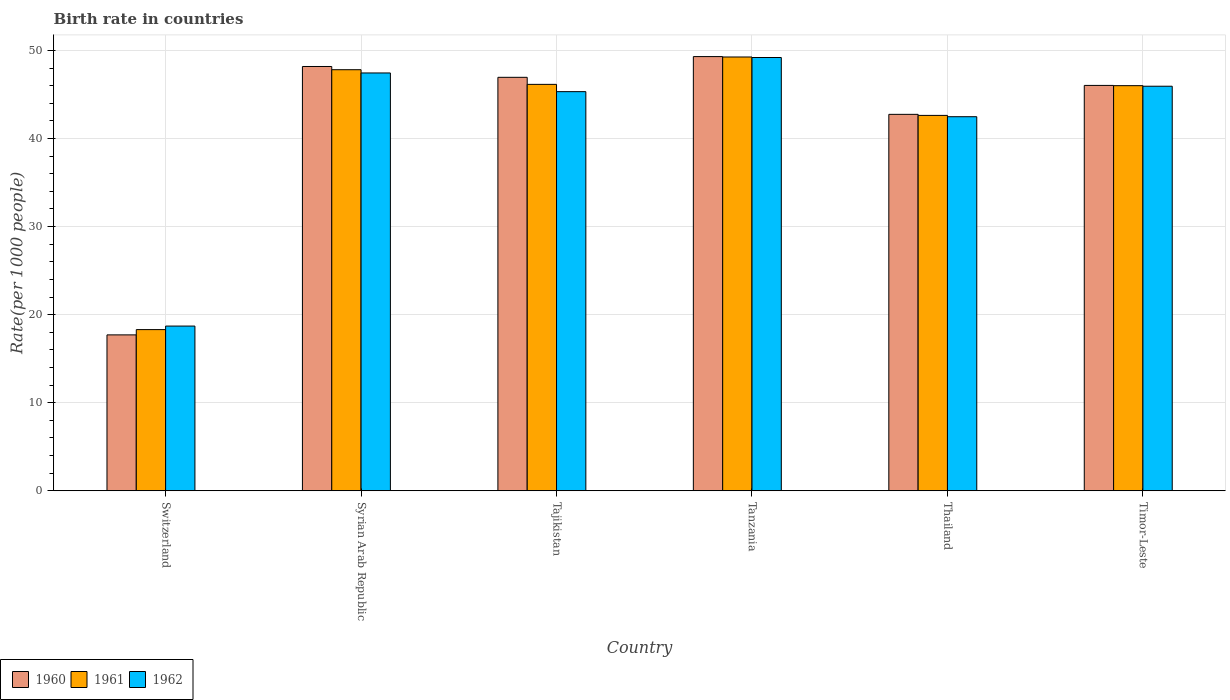Are the number of bars per tick equal to the number of legend labels?
Offer a very short reply. Yes. Are the number of bars on each tick of the X-axis equal?
Provide a short and direct response. Yes. What is the label of the 5th group of bars from the left?
Provide a short and direct response. Thailand. In how many cases, is the number of bars for a given country not equal to the number of legend labels?
Keep it short and to the point. 0. What is the birth rate in 1961 in Syrian Arab Republic?
Give a very brief answer. 47.8. Across all countries, what is the maximum birth rate in 1962?
Keep it short and to the point. 49.19. In which country was the birth rate in 1960 maximum?
Your answer should be compact. Tanzania. In which country was the birth rate in 1961 minimum?
Provide a short and direct response. Switzerland. What is the total birth rate in 1960 in the graph?
Your answer should be very brief. 250.87. What is the difference between the birth rate in 1961 in Tanzania and that in Timor-Leste?
Your answer should be compact. 3.26. What is the difference between the birth rate in 1961 in Switzerland and the birth rate in 1962 in Timor-Leste?
Your answer should be compact. -27.63. What is the average birth rate in 1960 per country?
Provide a succinct answer. 41.81. What is the difference between the birth rate of/in 1960 and birth rate of/in 1961 in Tanzania?
Your answer should be compact. 0.05. What is the ratio of the birth rate in 1962 in Tanzania to that in Timor-Leste?
Give a very brief answer. 1.07. Is the birth rate in 1962 in Switzerland less than that in Timor-Leste?
Offer a terse response. Yes. What is the difference between the highest and the second highest birth rate in 1962?
Keep it short and to the point. 3.26. What is the difference between the highest and the lowest birth rate in 1962?
Keep it short and to the point. 30.49. In how many countries, is the birth rate in 1961 greater than the average birth rate in 1961 taken over all countries?
Your answer should be compact. 5. How many bars are there?
Keep it short and to the point. 18. Are all the bars in the graph horizontal?
Your answer should be compact. No. How many countries are there in the graph?
Keep it short and to the point. 6. What is the difference between two consecutive major ticks on the Y-axis?
Offer a very short reply. 10. How many legend labels are there?
Ensure brevity in your answer.  3. What is the title of the graph?
Your response must be concise. Birth rate in countries. What is the label or title of the Y-axis?
Your answer should be very brief. Rate(per 1000 people). What is the Rate(per 1000 people) in 1960 in Switzerland?
Provide a short and direct response. 17.7. What is the Rate(per 1000 people) of 1961 in Switzerland?
Offer a very short reply. 18.3. What is the Rate(per 1000 people) of 1960 in Syrian Arab Republic?
Provide a succinct answer. 48.17. What is the Rate(per 1000 people) in 1961 in Syrian Arab Republic?
Provide a succinct answer. 47.8. What is the Rate(per 1000 people) of 1962 in Syrian Arab Republic?
Provide a short and direct response. 47.44. What is the Rate(per 1000 people) in 1960 in Tajikistan?
Offer a very short reply. 46.94. What is the Rate(per 1000 people) of 1961 in Tajikistan?
Provide a succinct answer. 46.14. What is the Rate(per 1000 people) of 1962 in Tajikistan?
Keep it short and to the point. 45.31. What is the Rate(per 1000 people) in 1960 in Tanzania?
Your response must be concise. 49.3. What is the Rate(per 1000 people) in 1961 in Tanzania?
Ensure brevity in your answer.  49.25. What is the Rate(per 1000 people) in 1962 in Tanzania?
Your response must be concise. 49.19. What is the Rate(per 1000 people) of 1960 in Thailand?
Give a very brief answer. 42.74. What is the Rate(per 1000 people) in 1961 in Thailand?
Provide a short and direct response. 42.62. What is the Rate(per 1000 people) of 1962 in Thailand?
Provide a short and direct response. 42.47. What is the Rate(per 1000 people) of 1960 in Timor-Leste?
Keep it short and to the point. 46.02. What is the Rate(per 1000 people) of 1961 in Timor-Leste?
Your answer should be very brief. 45.99. What is the Rate(per 1000 people) in 1962 in Timor-Leste?
Your answer should be very brief. 45.93. Across all countries, what is the maximum Rate(per 1000 people) in 1960?
Your response must be concise. 49.3. Across all countries, what is the maximum Rate(per 1000 people) of 1961?
Ensure brevity in your answer.  49.25. Across all countries, what is the maximum Rate(per 1000 people) in 1962?
Provide a short and direct response. 49.19. Across all countries, what is the minimum Rate(per 1000 people) in 1960?
Your answer should be compact. 17.7. Across all countries, what is the minimum Rate(per 1000 people) of 1962?
Your answer should be compact. 18.7. What is the total Rate(per 1000 people) of 1960 in the graph?
Your answer should be compact. 250.87. What is the total Rate(per 1000 people) of 1961 in the graph?
Provide a short and direct response. 250.11. What is the total Rate(per 1000 people) in 1962 in the graph?
Offer a terse response. 249.04. What is the difference between the Rate(per 1000 people) of 1960 in Switzerland and that in Syrian Arab Republic?
Your answer should be compact. -30.47. What is the difference between the Rate(per 1000 people) of 1961 in Switzerland and that in Syrian Arab Republic?
Provide a short and direct response. -29.5. What is the difference between the Rate(per 1000 people) of 1962 in Switzerland and that in Syrian Arab Republic?
Ensure brevity in your answer.  -28.74. What is the difference between the Rate(per 1000 people) of 1960 in Switzerland and that in Tajikistan?
Provide a succinct answer. -29.24. What is the difference between the Rate(per 1000 people) of 1961 in Switzerland and that in Tajikistan?
Give a very brief answer. -27.84. What is the difference between the Rate(per 1000 people) of 1962 in Switzerland and that in Tajikistan?
Keep it short and to the point. -26.61. What is the difference between the Rate(per 1000 people) of 1960 in Switzerland and that in Tanzania?
Provide a succinct answer. -31.6. What is the difference between the Rate(per 1000 people) of 1961 in Switzerland and that in Tanzania?
Provide a short and direct response. -30.95. What is the difference between the Rate(per 1000 people) of 1962 in Switzerland and that in Tanzania?
Give a very brief answer. -30.49. What is the difference between the Rate(per 1000 people) in 1960 in Switzerland and that in Thailand?
Make the answer very short. -25.04. What is the difference between the Rate(per 1000 people) of 1961 in Switzerland and that in Thailand?
Offer a terse response. -24.32. What is the difference between the Rate(per 1000 people) of 1962 in Switzerland and that in Thailand?
Your response must be concise. -23.77. What is the difference between the Rate(per 1000 people) in 1960 in Switzerland and that in Timor-Leste?
Offer a terse response. -28.32. What is the difference between the Rate(per 1000 people) of 1961 in Switzerland and that in Timor-Leste?
Offer a very short reply. -27.69. What is the difference between the Rate(per 1000 people) of 1962 in Switzerland and that in Timor-Leste?
Give a very brief answer. -27.23. What is the difference between the Rate(per 1000 people) in 1960 in Syrian Arab Republic and that in Tajikistan?
Your answer should be compact. 1.23. What is the difference between the Rate(per 1000 people) in 1961 in Syrian Arab Republic and that in Tajikistan?
Ensure brevity in your answer.  1.66. What is the difference between the Rate(per 1000 people) in 1962 in Syrian Arab Republic and that in Tajikistan?
Your answer should be very brief. 2.12. What is the difference between the Rate(per 1000 people) of 1960 in Syrian Arab Republic and that in Tanzania?
Keep it short and to the point. -1.12. What is the difference between the Rate(per 1000 people) of 1961 in Syrian Arab Republic and that in Tanzania?
Your answer should be compact. -1.44. What is the difference between the Rate(per 1000 people) of 1962 in Syrian Arab Republic and that in Tanzania?
Make the answer very short. -1.75. What is the difference between the Rate(per 1000 people) of 1960 in Syrian Arab Republic and that in Thailand?
Your answer should be compact. 5.43. What is the difference between the Rate(per 1000 people) in 1961 in Syrian Arab Republic and that in Thailand?
Provide a succinct answer. 5.19. What is the difference between the Rate(per 1000 people) of 1962 in Syrian Arab Republic and that in Thailand?
Offer a terse response. 4.97. What is the difference between the Rate(per 1000 people) of 1960 in Syrian Arab Republic and that in Timor-Leste?
Keep it short and to the point. 2.15. What is the difference between the Rate(per 1000 people) of 1961 in Syrian Arab Republic and that in Timor-Leste?
Give a very brief answer. 1.81. What is the difference between the Rate(per 1000 people) of 1962 in Syrian Arab Republic and that in Timor-Leste?
Your response must be concise. 1.51. What is the difference between the Rate(per 1000 people) of 1960 in Tajikistan and that in Tanzania?
Your answer should be compact. -2.35. What is the difference between the Rate(per 1000 people) of 1961 in Tajikistan and that in Tanzania?
Give a very brief answer. -3.11. What is the difference between the Rate(per 1000 people) in 1962 in Tajikistan and that in Tanzania?
Keep it short and to the point. -3.88. What is the difference between the Rate(per 1000 people) of 1960 in Tajikistan and that in Thailand?
Offer a terse response. 4.21. What is the difference between the Rate(per 1000 people) of 1961 in Tajikistan and that in Thailand?
Ensure brevity in your answer.  3.52. What is the difference between the Rate(per 1000 people) of 1962 in Tajikistan and that in Thailand?
Your response must be concise. 2.85. What is the difference between the Rate(per 1000 people) in 1960 in Tajikistan and that in Timor-Leste?
Offer a terse response. 0.92. What is the difference between the Rate(per 1000 people) of 1961 in Tajikistan and that in Timor-Leste?
Provide a succinct answer. 0.15. What is the difference between the Rate(per 1000 people) in 1962 in Tajikistan and that in Timor-Leste?
Your answer should be compact. -0.61. What is the difference between the Rate(per 1000 people) of 1960 in Tanzania and that in Thailand?
Give a very brief answer. 6.56. What is the difference between the Rate(per 1000 people) in 1961 in Tanzania and that in Thailand?
Keep it short and to the point. 6.63. What is the difference between the Rate(per 1000 people) of 1962 in Tanzania and that in Thailand?
Provide a succinct answer. 6.72. What is the difference between the Rate(per 1000 people) of 1960 in Tanzania and that in Timor-Leste?
Provide a short and direct response. 3.27. What is the difference between the Rate(per 1000 people) in 1961 in Tanzania and that in Timor-Leste?
Provide a succinct answer. 3.25. What is the difference between the Rate(per 1000 people) in 1962 in Tanzania and that in Timor-Leste?
Make the answer very short. 3.26. What is the difference between the Rate(per 1000 people) in 1960 in Thailand and that in Timor-Leste?
Your response must be concise. -3.29. What is the difference between the Rate(per 1000 people) in 1961 in Thailand and that in Timor-Leste?
Ensure brevity in your answer.  -3.38. What is the difference between the Rate(per 1000 people) of 1962 in Thailand and that in Timor-Leste?
Make the answer very short. -3.46. What is the difference between the Rate(per 1000 people) in 1960 in Switzerland and the Rate(per 1000 people) in 1961 in Syrian Arab Republic?
Offer a terse response. -30.11. What is the difference between the Rate(per 1000 people) of 1960 in Switzerland and the Rate(per 1000 people) of 1962 in Syrian Arab Republic?
Offer a very short reply. -29.74. What is the difference between the Rate(per 1000 people) in 1961 in Switzerland and the Rate(per 1000 people) in 1962 in Syrian Arab Republic?
Provide a short and direct response. -29.14. What is the difference between the Rate(per 1000 people) of 1960 in Switzerland and the Rate(per 1000 people) of 1961 in Tajikistan?
Provide a succinct answer. -28.44. What is the difference between the Rate(per 1000 people) of 1960 in Switzerland and the Rate(per 1000 people) of 1962 in Tajikistan?
Give a very brief answer. -27.61. What is the difference between the Rate(per 1000 people) in 1961 in Switzerland and the Rate(per 1000 people) in 1962 in Tajikistan?
Give a very brief answer. -27.02. What is the difference between the Rate(per 1000 people) in 1960 in Switzerland and the Rate(per 1000 people) in 1961 in Tanzania?
Ensure brevity in your answer.  -31.55. What is the difference between the Rate(per 1000 people) in 1960 in Switzerland and the Rate(per 1000 people) in 1962 in Tanzania?
Make the answer very short. -31.49. What is the difference between the Rate(per 1000 people) of 1961 in Switzerland and the Rate(per 1000 people) of 1962 in Tanzania?
Offer a very short reply. -30.89. What is the difference between the Rate(per 1000 people) in 1960 in Switzerland and the Rate(per 1000 people) in 1961 in Thailand?
Provide a short and direct response. -24.92. What is the difference between the Rate(per 1000 people) of 1960 in Switzerland and the Rate(per 1000 people) of 1962 in Thailand?
Your answer should be very brief. -24.77. What is the difference between the Rate(per 1000 people) in 1961 in Switzerland and the Rate(per 1000 people) in 1962 in Thailand?
Keep it short and to the point. -24.17. What is the difference between the Rate(per 1000 people) of 1960 in Switzerland and the Rate(per 1000 people) of 1961 in Timor-Leste?
Your response must be concise. -28.29. What is the difference between the Rate(per 1000 people) of 1960 in Switzerland and the Rate(per 1000 people) of 1962 in Timor-Leste?
Offer a terse response. -28.23. What is the difference between the Rate(per 1000 people) of 1961 in Switzerland and the Rate(per 1000 people) of 1962 in Timor-Leste?
Your answer should be very brief. -27.63. What is the difference between the Rate(per 1000 people) in 1960 in Syrian Arab Republic and the Rate(per 1000 people) in 1961 in Tajikistan?
Ensure brevity in your answer.  2.03. What is the difference between the Rate(per 1000 people) in 1960 in Syrian Arab Republic and the Rate(per 1000 people) in 1962 in Tajikistan?
Provide a succinct answer. 2.86. What is the difference between the Rate(per 1000 people) in 1961 in Syrian Arab Republic and the Rate(per 1000 people) in 1962 in Tajikistan?
Provide a succinct answer. 2.49. What is the difference between the Rate(per 1000 people) in 1960 in Syrian Arab Republic and the Rate(per 1000 people) in 1961 in Tanzania?
Provide a short and direct response. -1.08. What is the difference between the Rate(per 1000 people) in 1960 in Syrian Arab Republic and the Rate(per 1000 people) in 1962 in Tanzania?
Provide a succinct answer. -1.02. What is the difference between the Rate(per 1000 people) in 1961 in Syrian Arab Republic and the Rate(per 1000 people) in 1962 in Tanzania?
Provide a succinct answer. -1.39. What is the difference between the Rate(per 1000 people) in 1960 in Syrian Arab Republic and the Rate(per 1000 people) in 1961 in Thailand?
Give a very brief answer. 5.55. What is the difference between the Rate(per 1000 people) in 1960 in Syrian Arab Republic and the Rate(per 1000 people) in 1962 in Thailand?
Offer a very short reply. 5.7. What is the difference between the Rate(per 1000 people) in 1961 in Syrian Arab Republic and the Rate(per 1000 people) in 1962 in Thailand?
Offer a terse response. 5.33. What is the difference between the Rate(per 1000 people) in 1960 in Syrian Arab Republic and the Rate(per 1000 people) in 1961 in Timor-Leste?
Your answer should be compact. 2.18. What is the difference between the Rate(per 1000 people) in 1960 in Syrian Arab Republic and the Rate(per 1000 people) in 1962 in Timor-Leste?
Offer a terse response. 2.24. What is the difference between the Rate(per 1000 people) in 1961 in Syrian Arab Republic and the Rate(per 1000 people) in 1962 in Timor-Leste?
Your response must be concise. 1.88. What is the difference between the Rate(per 1000 people) in 1960 in Tajikistan and the Rate(per 1000 people) in 1961 in Tanzania?
Your response must be concise. -2.31. What is the difference between the Rate(per 1000 people) of 1960 in Tajikistan and the Rate(per 1000 people) of 1962 in Tanzania?
Your response must be concise. -2.25. What is the difference between the Rate(per 1000 people) of 1961 in Tajikistan and the Rate(per 1000 people) of 1962 in Tanzania?
Make the answer very short. -3.05. What is the difference between the Rate(per 1000 people) of 1960 in Tajikistan and the Rate(per 1000 people) of 1961 in Thailand?
Provide a succinct answer. 4.32. What is the difference between the Rate(per 1000 people) in 1960 in Tajikistan and the Rate(per 1000 people) in 1962 in Thailand?
Your answer should be compact. 4.47. What is the difference between the Rate(per 1000 people) in 1961 in Tajikistan and the Rate(per 1000 people) in 1962 in Thailand?
Your answer should be compact. 3.67. What is the difference between the Rate(per 1000 people) of 1960 in Tajikistan and the Rate(per 1000 people) of 1961 in Timor-Leste?
Offer a terse response. 0.95. What is the difference between the Rate(per 1000 people) of 1961 in Tajikistan and the Rate(per 1000 people) of 1962 in Timor-Leste?
Ensure brevity in your answer.  0.21. What is the difference between the Rate(per 1000 people) in 1960 in Tanzania and the Rate(per 1000 people) in 1961 in Thailand?
Give a very brief answer. 6.68. What is the difference between the Rate(per 1000 people) of 1960 in Tanzania and the Rate(per 1000 people) of 1962 in Thailand?
Your answer should be compact. 6.83. What is the difference between the Rate(per 1000 people) of 1961 in Tanzania and the Rate(per 1000 people) of 1962 in Thailand?
Make the answer very short. 6.78. What is the difference between the Rate(per 1000 people) in 1960 in Tanzania and the Rate(per 1000 people) in 1961 in Timor-Leste?
Provide a short and direct response. 3.3. What is the difference between the Rate(per 1000 people) of 1960 in Tanzania and the Rate(per 1000 people) of 1962 in Timor-Leste?
Give a very brief answer. 3.37. What is the difference between the Rate(per 1000 people) in 1961 in Tanzania and the Rate(per 1000 people) in 1962 in Timor-Leste?
Ensure brevity in your answer.  3.32. What is the difference between the Rate(per 1000 people) in 1960 in Thailand and the Rate(per 1000 people) in 1961 in Timor-Leste?
Your answer should be very brief. -3.26. What is the difference between the Rate(per 1000 people) of 1960 in Thailand and the Rate(per 1000 people) of 1962 in Timor-Leste?
Ensure brevity in your answer.  -3.19. What is the difference between the Rate(per 1000 people) in 1961 in Thailand and the Rate(per 1000 people) in 1962 in Timor-Leste?
Give a very brief answer. -3.31. What is the average Rate(per 1000 people) in 1960 per country?
Your response must be concise. 41.81. What is the average Rate(per 1000 people) in 1961 per country?
Offer a very short reply. 41.68. What is the average Rate(per 1000 people) of 1962 per country?
Give a very brief answer. 41.51. What is the difference between the Rate(per 1000 people) of 1960 and Rate(per 1000 people) of 1961 in Switzerland?
Your answer should be compact. -0.6. What is the difference between the Rate(per 1000 people) of 1960 and Rate(per 1000 people) of 1962 in Switzerland?
Make the answer very short. -1. What is the difference between the Rate(per 1000 people) of 1960 and Rate(per 1000 people) of 1961 in Syrian Arab Republic?
Offer a very short reply. 0.37. What is the difference between the Rate(per 1000 people) of 1960 and Rate(per 1000 people) of 1962 in Syrian Arab Republic?
Make the answer very short. 0.73. What is the difference between the Rate(per 1000 people) of 1961 and Rate(per 1000 people) of 1962 in Syrian Arab Republic?
Keep it short and to the point. 0.37. What is the difference between the Rate(per 1000 people) of 1960 and Rate(per 1000 people) of 1961 in Tajikistan?
Your answer should be very brief. 0.8. What is the difference between the Rate(per 1000 people) in 1960 and Rate(per 1000 people) in 1962 in Tajikistan?
Give a very brief answer. 1.63. What is the difference between the Rate(per 1000 people) of 1961 and Rate(per 1000 people) of 1962 in Tajikistan?
Offer a very short reply. 0.83. What is the difference between the Rate(per 1000 people) of 1960 and Rate(per 1000 people) of 1961 in Tanzania?
Your answer should be very brief. 0.05. What is the difference between the Rate(per 1000 people) of 1960 and Rate(per 1000 people) of 1962 in Tanzania?
Your answer should be very brief. 0.1. What is the difference between the Rate(per 1000 people) in 1961 and Rate(per 1000 people) in 1962 in Tanzania?
Give a very brief answer. 0.06. What is the difference between the Rate(per 1000 people) of 1960 and Rate(per 1000 people) of 1961 in Thailand?
Offer a terse response. 0.12. What is the difference between the Rate(per 1000 people) of 1960 and Rate(per 1000 people) of 1962 in Thailand?
Provide a succinct answer. 0.27. What is the difference between the Rate(per 1000 people) of 1961 and Rate(per 1000 people) of 1962 in Thailand?
Your answer should be compact. 0.15. What is the difference between the Rate(per 1000 people) of 1960 and Rate(per 1000 people) of 1961 in Timor-Leste?
Your answer should be very brief. 0.03. What is the difference between the Rate(per 1000 people) of 1960 and Rate(per 1000 people) of 1962 in Timor-Leste?
Your answer should be compact. 0.09. What is the difference between the Rate(per 1000 people) of 1961 and Rate(per 1000 people) of 1962 in Timor-Leste?
Offer a very short reply. 0.06. What is the ratio of the Rate(per 1000 people) in 1960 in Switzerland to that in Syrian Arab Republic?
Offer a terse response. 0.37. What is the ratio of the Rate(per 1000 people) of 1961 in Switzerland to that in Syrian Arab Republic?
Offer a terse response. 0.38. What is the ratio of the Rate(per 1000 people) in 1962 in Switzerland to that in Syrian Arab Republic?
Give a very brief answer. 0.39. What is the ratio of the Rate(per 1000 people) in 1960 in Switzerland to that in Tajikistan?
Provide a short and direct response. 0.38. What is the ratio of the Rate(per 1000 people) of 1961 in Switzerland to that in Tajikistan?
Give a very brief answer. 0.4. What is the ratio of the Rate(per 1000 people) in 1962 in Switzerland to that in Tajikistan?
Offer a terse response. 0.41. What is the ratio of the Rate(per 1000 people) in 1960 in Switzerland to that in Tanzania?
Your response must be concise. 0.36. What is the ratio of the Rate(per 1000 people) of 1961 in Switzerland to that in Tanzania?
Offer a terse response. 0.37. What is the ratio of the Rate(per 1000 people) in 1962 in Switzerland to that in Tanzania?
Offer a very short reply. 0.38. What is the ratio of the Rate(per 1000 people) in 1960 in Switzerland to that in Thailand?
Your answer should be compact. 0.41. What is the ratio of the Rate(per 1000 people) of 1961 in Switzerland to that in Thailand?
Your response must be concise. 0.43. What is the ratio of the Rate(per 1000 people) of 1962 in Switzerland to that in Thailand?
Offer a terse response. 0.44. What is the ratio of the Rate(per 1000 people) of 1960 in Switzerland to that in Timor-Leste?
Provide a short and direct response. 0.38. What is the ratio of the Rate(per 1000 people) of 1961 in Switzerland to that in Timor-Leste?
Your answer should be very brief. 0.4. What is the ratio of the Rate(per 1000 people) in 1962 in Switzerland to that in Timor-Leste?
Your response must be concise. 0.41. What is the ratio of the Rate(per 1000 people) in 1960 in Syrian Arab Republic to that in Tajikistan?
Keep it short and to the point. 1.03. What is the ratio of the Rate(per 1000 people) in 1961 in Syrian Arab Republic to that in Tajikistan?
Your response must be concise. 1.04. What is the ratio of the Rate(per 1000 people) of 1962 in Syrian Arab Republic to that in Tajikistan?
Give a very brief answer. 1.05. What is the ratio of the Rate(per 1000 people) in 1960 in Syrian Arab Republic to that in Tanzania?
Provide a succinct answer. 0.98. What is the ratio of the Rate(per 1000 people) of 1961 in Syrian Arab Republic to that in Tanzania?
Provide a short and direct response. 0.97. What is the ratio of the Rate(per 1000 people) in 1962 in Syrian Arab Republic to that in Tanzania?
Make the answer very short. 0.96. What is the ratio of the Rate(per 1000 people) of 1960 in Syrian Arab Republic to that in Thailand?
Offer a terse response. 1.13. What is the ratio of the Rate(per 1000 people) in 1961 in Syrian Arab Republic to that in Thailand?
Offer a terse response. 1.12. What is the ratio of the Rate(per 1000 people) of 1962 in Syrian Arab Republic to that in Thailand?
Offer a very short reply. 1.12. What is the ratio of the Rate(per 1000 people) of 1960 in Syrian Arab Republic to that in Timor-Leste?
Your answer should be very brief. 1.05. What is the ratio of the Rate(per 1000 people) of 1961 in Syrian Arab Republic to that in Timor-Leste?
Provide a succinct answer. 1.04. What is the ratio of the Rate(per 1000 people) of 1962 in Syrian Arab Republic to that in Timor-Leste?
Your answer should be very brief. 1.03. What is the ratio of the Rate(per 1000 people) of 1960 in Tajikistan to that in Tanzania?
Keep it short and to the point. 0.95. What is the ratio of the Rate(per 1000 people) in 1961 in Tajikistan to that in Tanzania?
Your response must be concise. 0.94. What is the ratio of the Rate(per 1000 people) in 1962 in Tajikistan to that in Tanzania?
Provide a succinct answer. 0.92. What is the ratio of the Rate(per 1000 people) of 1960 in Tajikistan to that in Thailand?
Provide a short and direct response. 1.1. What is the ratio of the Rate(per 1000 people) in 1961 in Tajikistan to that in Thailand?
Your answer should be compact. 1.08. What is the ratio of the Rate(per 1000 people) of 1962 in Tajikistan to that in Thailand?
Offer a terse response. 1.07. What is the ratio of the Rate(per 1000 people) of 1960 in Tajikistan to that in Timor-Leste?
Your answer should be compact. 1.02. What is the ratio of the Rate(per 1000 people) of 1962 in Tajikistan to that in Timor-Leste?
Offer a terse response. 0.99. What is the ratio of the Rate(per 1000 people) of 1960 in Tanzania to that in Thailand?
Make the answer very short. 1.15. What is the ratio of the Rate(per 1000 people) of 1961 in Tanzania to that in Thailand?
Offer a very short reply. 1.16. What is the ratio of the Rate(per 1000 people) of 1962 in Tanzania to that in Thailand?
Your response must be concise. 1.16. What is the ratio of the Rate(per 1000 people) of 1960 in Tanzania to that in Timor-Leste?
Your answer should be very brief. 1.07. What is the ratio of the Rate(per 1000 people) of 1961 in Tanzania to that in Timor-Leste?
Give a very brief answer. 1.07. What is the ratio of the Rate(per 1000 people) of 1962 in Tanzania to that in Timor-Leste?
Your answer should be very brief. 1.07. What is the ratio of the Rate(per 1000 people) in 1960 in Thailand to that in Timor-Leste?
Provide a short and direct response. 0.93. What is the ratio of the Rate(per 1000 people) of 1961 in Thailand to that in Timor-Leste?
Offer a very short reply. 0.93. What is the ratio of the Rate(per 1000 people) of 1962 in Thailand to that in Timor-Leste?
Offer a very short reply. 0.92. What is the difference between the highest and the second highest Rate(per 1000 people) in 1960?
Your answer should be compact. 1.12. What is the difference between the highest and the second highest Rate(per 1000 people) in 1961?
Keep it short and to the point. 1.44. What is the difference between the highest and the second highest Rate(per 1000 people) of 1962?
Ensure brevity in your answer.  1.75. What is the difference between the highest and the lowest Rate(per 1000 people) in 1960?
Your answer should be very brief. 31.6. What is the difference between the highest and the lowest Rate(per 1000 people) of 1961?
Keep it short and to the point. 30.95. What is the difference between the highest and the lowest Rate(per 1000 people) of 1962?
Provide a succinct answer. 30.49. 